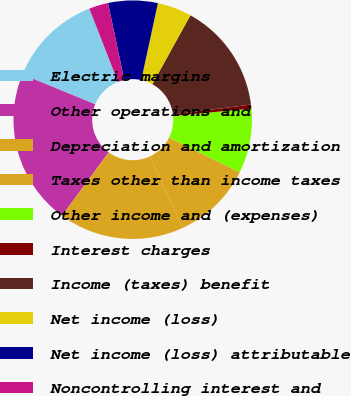<chart> <loc_0><loc_0><loc_500><loc_500><pie_chart><fcel>Electric margins<fcel>Other operations and<fcel>Depreciation and amortization<fcel>Taxes other than income taxes<fcel>Other income and (expenses)<fcel>Interest charges<fcel>Income (taxes) benefit<fcel>Net income (loss)<fcel>Net income (loss) attributable<fcel>Noncontrolling interest and<nl><fcel>12.88%<fcel>21.1%<fcel>16.99%<fcel>10.82%<fcel>8.77%<fcel>0.54%<fcel>14.94%<fcel>4.65%<fcel>6.71%<fcel>2.6%<nl></chart> 